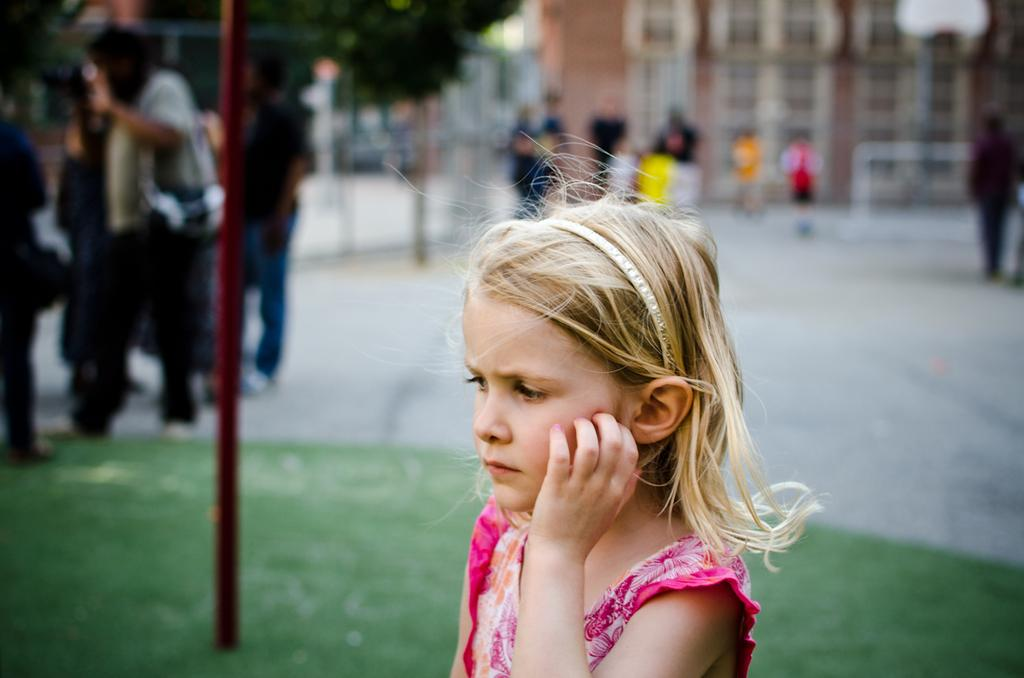Who is the main subject in the image? There is a girl in the image. What is the girl wearing? The girl is wearing a pink dress. What can be seen in the background of the image? There are people, places, buildings, and trees in the background of the image. How much money is the girl holding in the image? There is no indication of money in the image; the girl is not holding any money. 